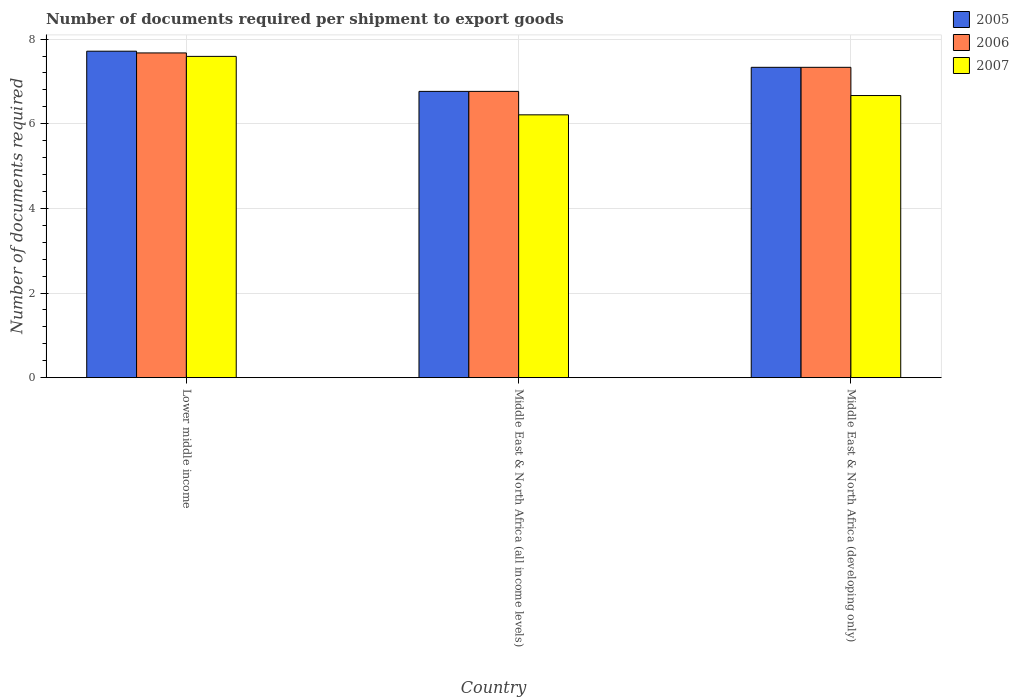How many different coloured bars are there?
Your answer should be very brief. 3. How many bars are there on the 2nd tick from the left?
Your answer should be very brief. 3. How many bars are there on the 3rd tick from the right?
Provide a succinct answer. 3. What is the label of the 3rd group of bars from the left?
Give a very brief answer. Middle East & North Africa (developing only). What is the number of documents required per shipment to export goods in 2007 in Middle East & North Africa (all income levels)?
Offer a terse response. 6.21. Across all countries, what is the maximum number of documents required per shipment to export goods in 2006?
Provide a short and direct response. 7.67. Across all countries, what is the minimum number of documents required per shipment to export goods in 2006?
Provide a short and direct response. 6.76. In which country was the number of documents required per shipment to export goods in 2007 maximum?
Keep it short and to the point. Lower middle income. In which country was the number of documents required per shipment to export goods in 2006 minimum?
Give a very brief answer. Middle East & North Africa (all income levels). What is the total number of documents required per shipment to export goods in 2005 in the graph?
Your answer should be compact. 21.81. What is the difference between the number of documents required per shipment to export goods in 2005 in Lower middle income and that in Middle East & North Africa (developing only)?
Your answer should be compact. 0.38. What is the difference between the number of documents required per shipment to export goods in 2007 in Middle East & North Africa (developing only) and the number of documents required per shipment to export goods in 2005 in Middle East & North Africa (all income levels)?
Make the answer very short. -0.1. What is the average number of documents required per shipment to export goods in 2006 per country?
Your response must be concise. 7.26. What is the difference between the number of documents required per shipment to export goods of/in 2006 and number of documents required per shipment to export goods of/in 2007 in Lower middle income?
Give a very brief answer. 0.08. In how many countries, is the number of documents required per shipment to export goods in 2005 greater than 2.8?
Offer a very short reply. 3. What is the ratio of the number of documents required per shipment to export goods in 2006 in Middle East & North Africa (all income levels) to that in Middle East & North Africa (developing only)?
Your answer should be very brief. 0.92. Is the difference between the number of documents required per shipment to export goods in 2006 in Middle East & North Africa (all income levels) and Middle East & North Africa (developing only) greater than the difference between the number of documents required per shipment to export goods in 2007 in Middle East & North Africa (all income levels) and Middle East & North Africa (developing only)?
Provide a succinct answer. No. What is the difference between the highest and the second highest number of documents required per shipment to export goods in 2005?
Your answer should be very brief. 0.57. What is the difference between the highest and the lowest number of documents required per shipment to export goods in 2006?
Offer a terse response. 0.91. What does the 3rd bar from the left in Middle East & North Africa (all income levels) represents?
Make the answer very short. 2007. Are all the bars in the graph horizontal?
Ensure brevity in your answer.  No. What is the difference between two consecutive major ticks on the Y-axis?
Give a very brief answer. 2. Does the graph contain grids?
Provide a succinct answer. Yes. How many legend labels are there?
Provide a short and direct response. 3. What is the title of the graph?
Ensure brevity in your answer.  Number of documents required per shipment to export goods. Does "1963" appear as one of the legend labels in the graph?
Your answer should be very brief. No. What is the label or title of the X-axis?
Offer a very short reply. Country. What is the label or title of the Y-axis?
Make the answer very short. Number of documents required. What is the Number of documents required of 2005 in Lower middle income?
Your answer should be very brief. 7.71. What is the Number of documents required in 2006 in Lower middle income?
Your answer should be very brief. 7.67. What is the Number of documents required in 2007 in Lower middle income?
Offer a terse response. 7.59. What is the Number of documents required in 2005 in Middle East & North Africa (all income levels)?
Offer a terse response. 6.76. What is the Number of documents required of 2006 in Middle East & North Africa (all income levels)?
Your answer should be very brief. 6.76. What is the Number of documents required of 2007 in Middle East & North Africa (all income levels)?
Make the answer very short. 6.21. What is the Number of documents required of 2005 in Middle East & North Africa (developing only)?
Ensure brevity in your answer.  7.33. What is the Number of documents required in 2006 in Middle East & North Africa (developing only)?
Offer a terse response. 7.33. What is the Number of documents required of 2007 in Middle East & North Africa (developing only)?
Your answer should be compact. 6.67. Across all countries, what is the maximum Number of documents required of 2005?
Your response must be concise. 7.71. Across all countries, what is the maximum Number of documents required of 2006?
Provide a succinct answer. 7.67. Across all countries, what is the maximum Number of documents required in 2007?
Provide a short and direct response. 7.59. Across all countries, what is the minimum Number of documents required of 2005?
Ensure brevity in your answer.  6.76. Across all countries, what is the minimum Number of documents required in 2006?
Give a very brief answer. 6.76. Across all countries, what is the minimum Number of documents required of 2007?
Your answer should be very brief. 6.21. What is the total Number of documents required of 2005 in the graph?
Give a very brief answer. 21.81. What is the total Number of documents required in 2006 in the graph?
Your response must be concise. 21.77. What is the total Number of documents required of 2007 in the graph?
Provide a short and direct response. 20.47. What is the difference between the Number of documents required of 2005 in Lower middle income and that in Middle East & North Africa (all income levels)?
Make the answer very short. 0.95. What is the difference between the Number of documents required of 2006 in Lower middle income and that in Middle East & North Africa (all income levels)?
Give a very brief answer. 0.91. What is the difference between the Number of documents required of 2007 in Lower middle income and that in Middle East & North Africa (all income levels)?
Give a very brief answer. 1.38. What is the difference between the Number of documents required in 2005 in Lower middle income and that in Middle East & North Africa (developing only)?
Your response must be concise. 0.38. What is the difference between the Number of documents required in 2006 in Lower middle income and that in Middle East & North Africa (developing only)?
Give a very brief answer. 0.34. What is the difference between the Number of documents required in 2007 in Lower middle income and that in Middle East & North Africa (developing only)?
Your response must be concise. 0.93. What is the difference between the Number of documents required of 2005 in Middle East & North Africa (all income levels) and that in Middle East & North Africa (developing only)?
Offer a very short reply. -0.57. What is the difference between the Number of documents required in 2006 in Middle East & North Africa (all income levels) and that in Middle East & North Africa (developing only)?
Offer a terse response. -0.57. What is the difference between the Number of documents required in 2007 in Middle East & North Africa (all income levels) and that in Middle East & North Africa (developing only)?
Provide a succinct answer. -0.46. What is the difference between the Number of documents required in 2005 in Lower middle income and the Number of documents required in 2006 in Middle East & North Africa (all income levels)?
Your answer should be very brief. 0.95. What is the difference between the Number of documents required of 2005 in Lower middle income and the Number of documents required of 2007 in Middle East & North Africa (all income levels)?
Your response must be concise. 1.5. What is the difference between the Number of documents required of 2006 in Lower middle income and the Number of documents required of 2007 in Middle East & North Africa (all income levels)?
Provide a short and direct response. 1.46. What is the difference between the Number of documents required in 2005 in Lower middle income and the Number of documents required in 2006 in Middle East & North Africa (developing only)?
Your response must be concise. 0.38. What is the difference between the Number of documents required of 2005 in Lower middle income and the Number of documents required of 2007 in Middle East & North Africa (developing only)?
Keep it short and to the point. 1.05. What is the difference between the Number of documents required of 2006 in Lower middle income and the Number of documents required of 2007 in Middle East & North Africa (developing only)?
Make the answer very short. 1.01. What is the difference between the Number of documents required in 2005 in Middle East & North Africa (all income levels) and the Number of documents required in 2006 in Middle East & North Africa (developing only)?
Provide a short and direct response. -0.57. What is the difference between the Number of documents required in 2005 in Middle East & North Africa (all income levels) and the Number of documents required in 2007 in Middle East & North Africa (developing only)?
Keep it short and to the point. 0.1. What is the difference between the Number of documents required in 2006 in Middle East & North Africa (all income levels) and the Number of documents required in 2007 in Middle East & North Africa (developing only)?
Offer a very short reply. 0.1. What is the average Number of documents required of 2005 per country?
Your response must be concise. 7.27. What is the average Number of documents required of 2006 per country?
Provide a succinct answer. 7.26. What is the average Number of documents required of 2007 per country?
Make the answer very short. 6.82. What is the difference between the Number of documents required of 2005 and Number of documents required of 2006 in Lower middle income?
Your response must be concise. 0.04. What is the difference between the Number of documents required in 2005 and Number of documents required in 2007 in Lower middle income?
Your answer should be very brief. 0.12. What is the difference between the Number of documents required in 2006 and Number of documents required in 2007 in Lower middle income?
Ensure brevity in your answer.  0.08. What is the difference between the Number of documents required of 2005 and Number of documents required of 2007 in Middle East & North Africa (all income levels)?
Make the answer very short. 0.55. What is the difference between the Number of documents required in 2006 and Number of documents required in 2007 in Middle East & North Africa (all income levels)?
Offer a terse response. 0.55. What is the difference between the Number of documents required in 2005 and Number of documents required in 2006 in Middle East & North Africa (developing only)?
Your answer should be compact. 0. What is the difference between the Number of documents required of 2006 and Number of documents required of 2007 in Middle East & North Africa (developing only)?
Offer a terse response. 0.67. What is the ratio of the Number of documents required of 2005 in Lower middle income to that in Middle East & North Africa (all income levels)?
Keep it short and to the point. 1.14. What is the ratio of the Number of documents required in 2006 in Lower middle income to that in Middle East & North Africa (all income levels)?
Your response must be concise. 1.13. What is the ratio of the Number of documents required in 2007 in Lower middle income to that in Middle East & North Africa (all income levels)?
Your answer should be compact. 1.22. What is the ratio of the Number of documents required in 2005 in Lower middle income to that in Middle East & North Africa (developing only)?
Keep it short and to the point. 1.05. What is the ratio of the Number of documents required of 2006 in Lower middle income to that in Middle East & North Africa (developing only)?
Provide a succinct answer. 1.05. What is the ratio of the Number of documents required in 2007 in Lower middle income to that in Middle East & North Africa (developing only)?
Your answer should be very brief. 1.14. What is the ratio of the Number of documents required in 2005 in Middle East & North Africa (all income levels) to that in Middle East & North Africa (developing only)?
Your answer should be very brief. 0.92. What is the ratio of the Number of documents required of 2006 in Middle East & North Africa (all income levels) to that in Middle East & North Africa (developing only)?
Offer a terse response. 0.92. What is the ratio of the Number of documents required in 2007 in Middle East & North Africa (all income levels) to that in Middle East & North Africa (developing only)?
Provide a succinct answer. 0.93. What is the difference between the highest and the second highest Number of documents required of 2005?
Provide a short and direct response. 0.38. What is the difference between the highest and the second highest Number of documents required of 2006?
Provide a short and direct response. 0.34. What is the difference between the highest and the second highest Number of documents required of 2007?
Offer a very short reply. 0.93. What is the difference between the highest and the lowest Number of documents required of 2005?
Give a very brief answer. 0.95. What is the difference between the highest and the lowest Number of documents required in 2006?
Ensure brevity in your answer.  0.91. What is the difference between the highest and the lowest Number of documents required of 2007?
Your answer should be very brief. 1.38. 